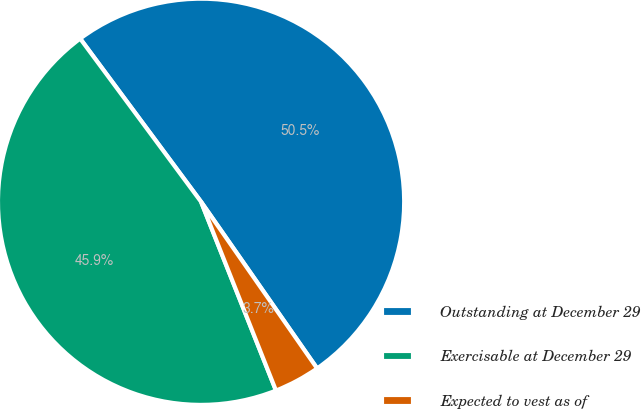Convert chart to OTSL. <chart><loc_0><loc_0><loc_500><loc_500><pie_chart><fcel>Outstanding at December 29<fcel>Exercisable at December 29<fcel>Expected to vest as of<nl><fcel>50.47%<fcel>45.87%<fcel>3.67%<nl></chart> 